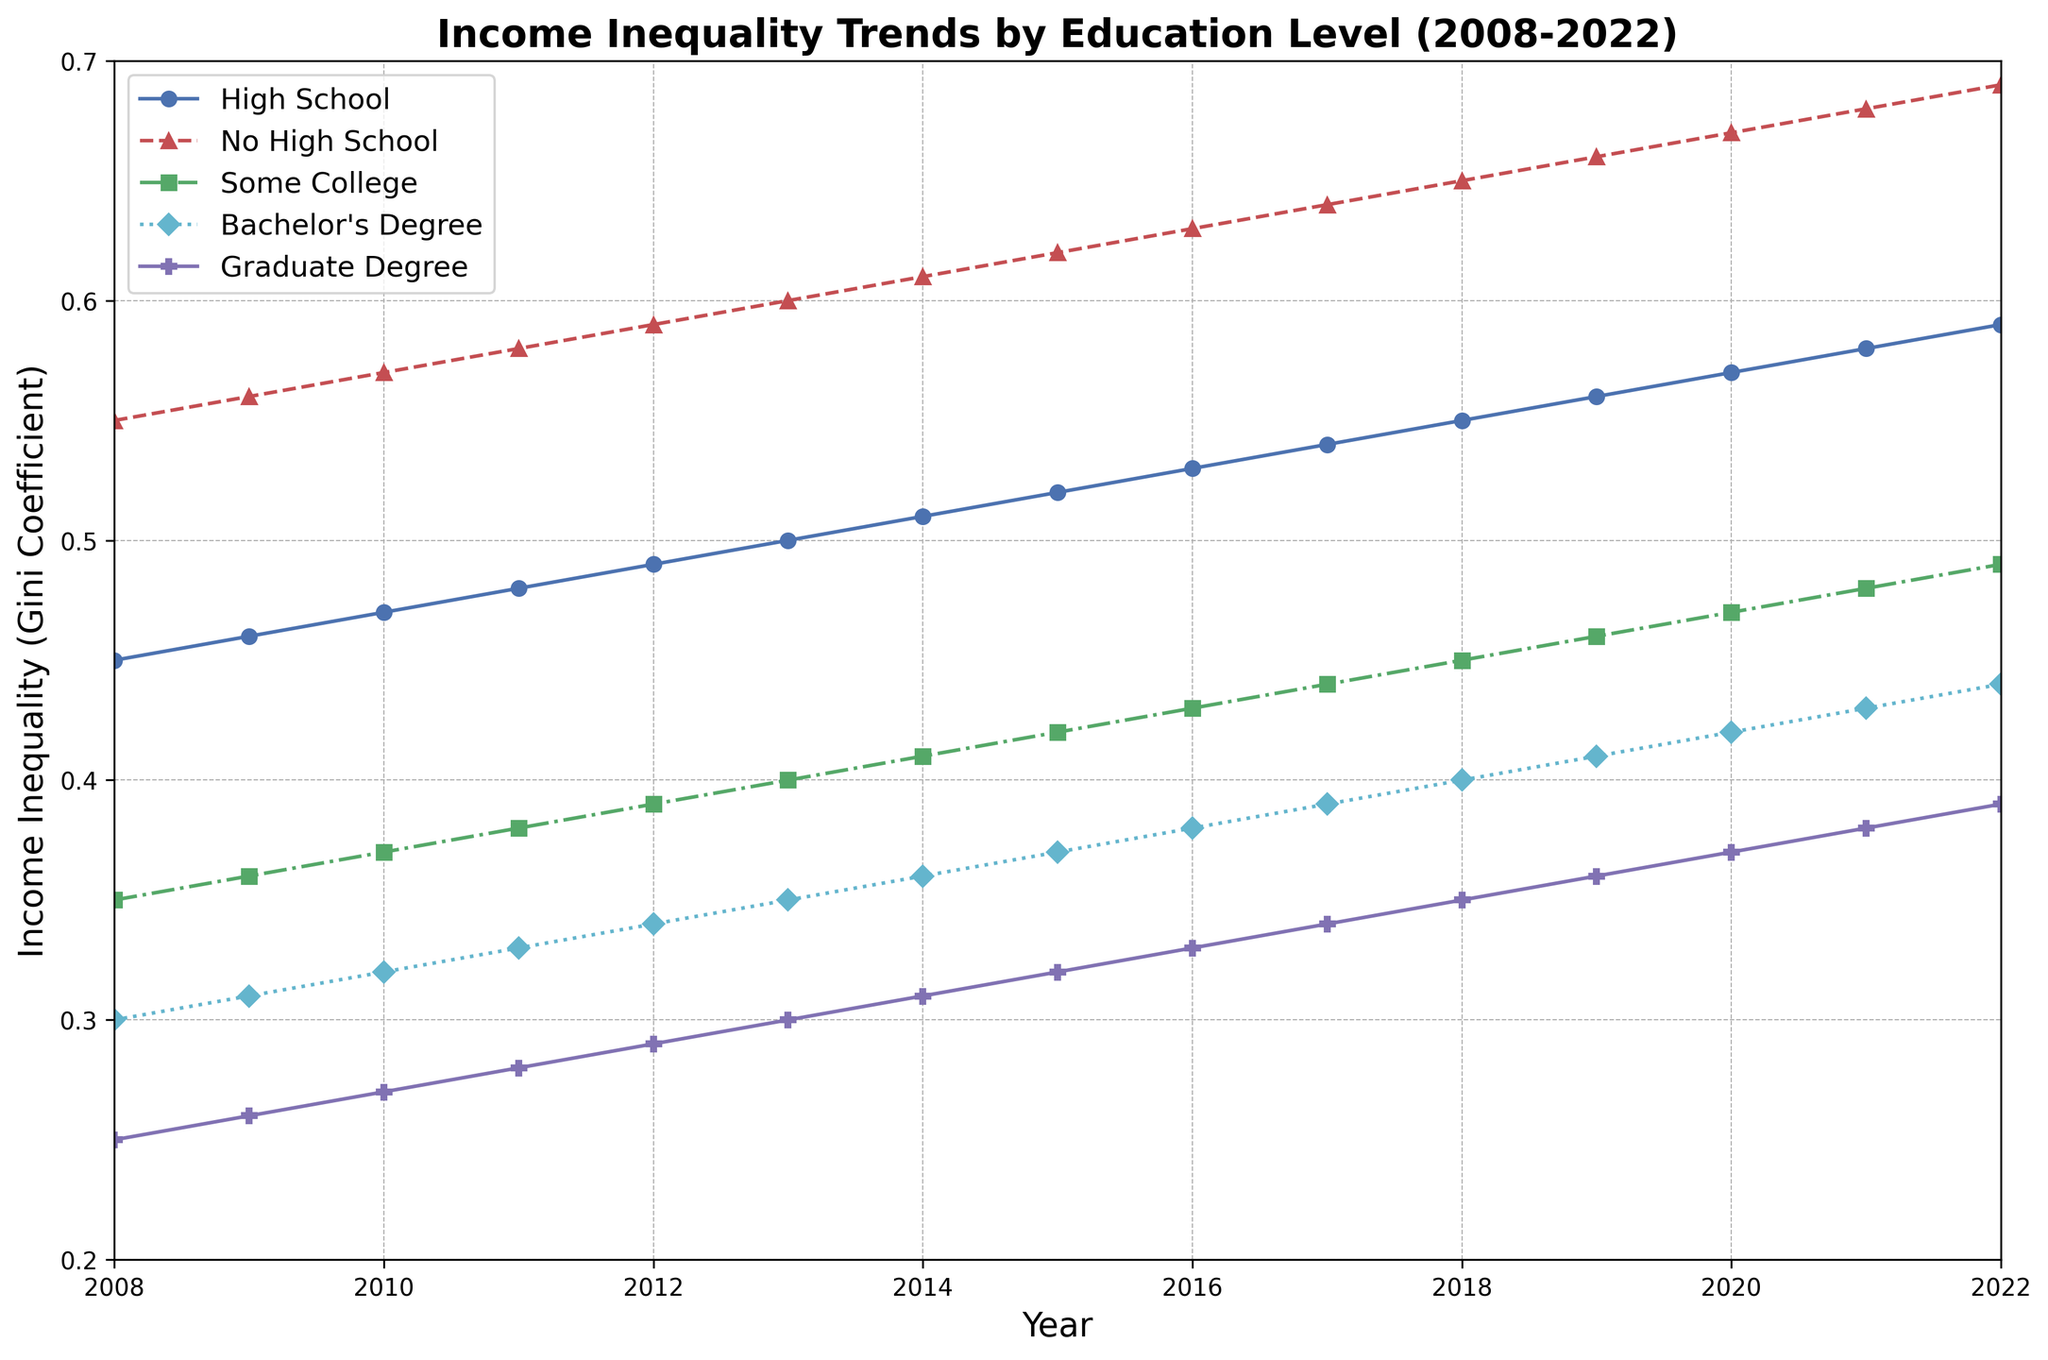What general trend do you notice for people with no high school education over the 15 years? From 2008 to 2022, the line representing people with no high school education shows a clear upward trend, indicating that income inequality for this group has been increasing steadily.
Answer: Increasing trend Which educational attainment category has the lowest income inequality in the year 2022? In 2022, the line for the group with a graduate degree is at the lowest point on the y-axis compared to other groups.
Answer: Graduate degree How does the income inequality for those with some college education in 2015 compare to those with a bachelor's degree in 2010? In 2015, the Gini coefficient for some college is 0.42, whereas in 2010, the Gini coefficient for bachelor's degree is 0.32, showing that income inequality is higher for those with some college education in 2015 compared to those with a bachelor's degree in 2010.
Answer: Higher By how much has the income inequality for high school graduates increased from 2008 to 2022? The Gini coefficient for high school graduates was 0.45 in 2008 and increased to 0.59 in 2022. The difference is 0.59 - 0.45 = 0.14.
Answer: 0.14 What is the average Gini coefficient for those with a bachelor's degree over the given period? Summing the Gini coefficients for those with a bachelor's degree from 2008 to 2022: (0.30 + 0.31 + 0.32 + 0.33 + 0.34 + 0.35 + 0.36 + 0.37 + 0.38 + 0.39 + 0.40 + 0.41 + 0.42 + 0.43 + 0.44) = 5.97. There are 15 years, so the average is 5.97 / 15 ≈ 0.398.
Answer: 0.398 Which group shows the highest increase in income inequality from the start to the end of the period? By comparing the increase in Gini coefficients for each group from 2008 to 2022, we find: High School (0.59 - 0.45 = 0.14), No High School (0.69 - 0.55 = 0.14), Some College (0.49 - 0.35 = 0.14), Bachelor's (0.44 - 0.30 = 0.14), Graduate (0.39 - 0.25 = 0.14). All groups show an equal increase of 0.14 over the period.
Answer: All groups Which year shows a crossing point between the lines representing high school and some college education groups, if any? The lines for high school and some college education do not intersect at any point in the given time frame.
Answer: None Between 2018 and 2022, which group had the smallest change in income inequality? Comparing the Gini coefficients from 2018 to 2022, the differences are: High School (0.04), No High School (0.04), Some College (0.04), Bachelor's (0.04), Graduate (0.04). All groups had the same change of 0.04.
Answer: All groups 